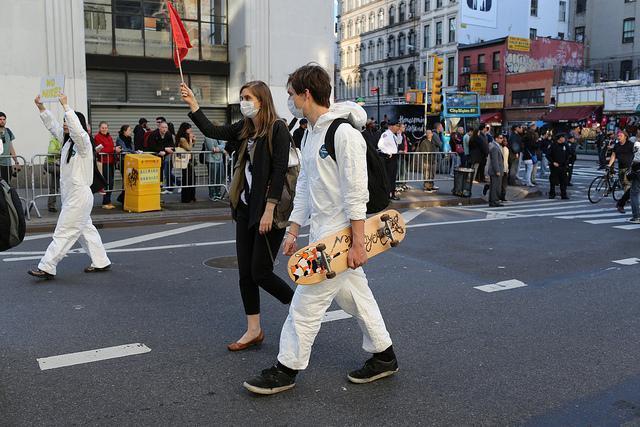How many newsstands are there?
Give a very brief answer. 1. How many people are there?
Give a very brief answer. 4. How many ski boards are in the picture?
Give a very brief answer. 0. 